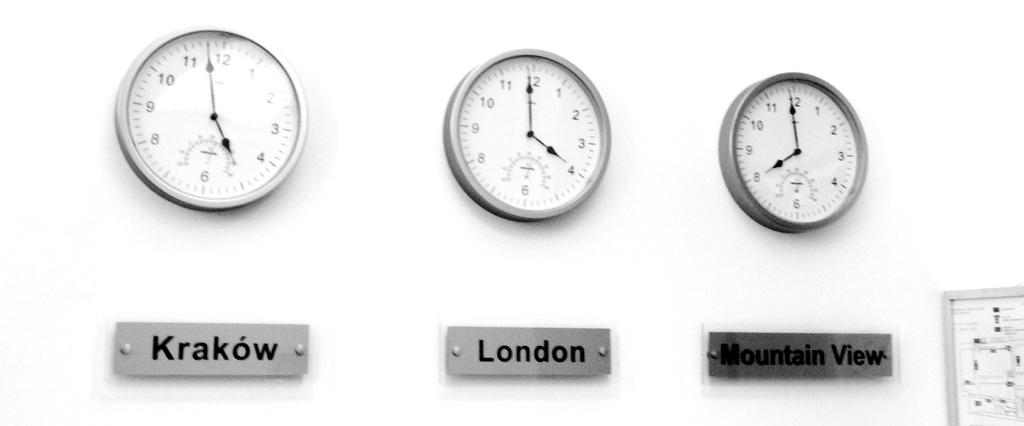<image>
Render a clear and concise summary of the photo. Three clocks with the times for Krakow, London and Mountain View. 